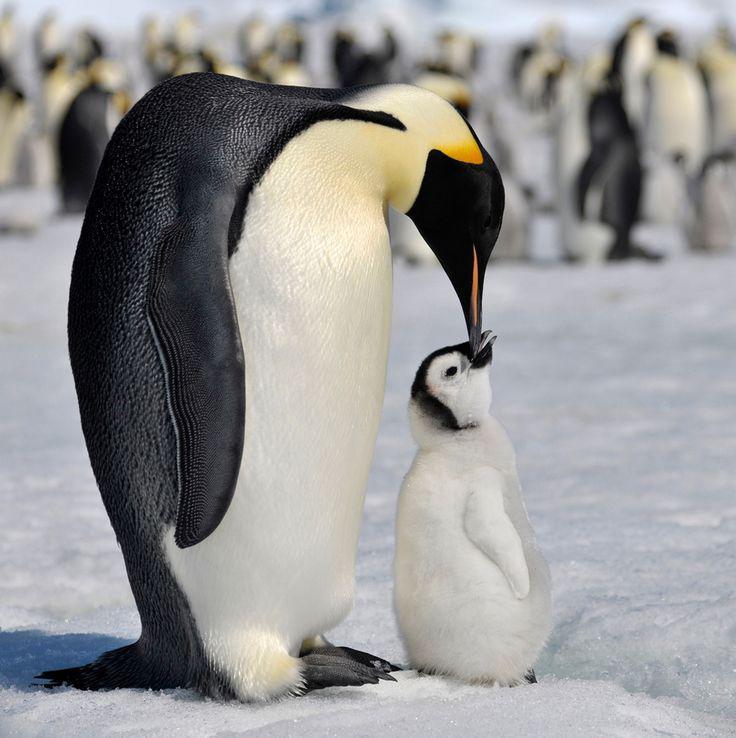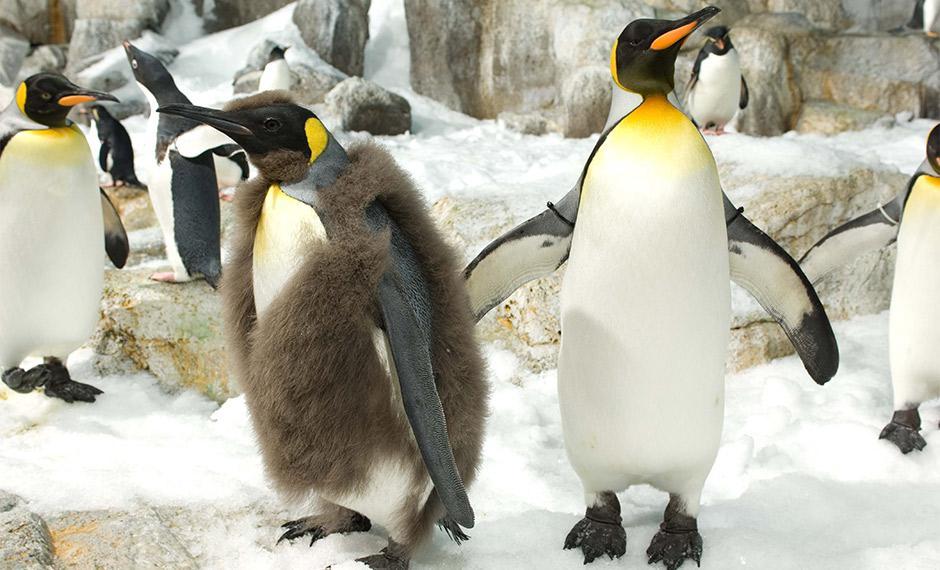The first image is the image on the left, the second image is the image on the right. Considering the images on both sides, is "1 of the penguins has brown fuzz on it." valid? Answer yes or no. Yes. 